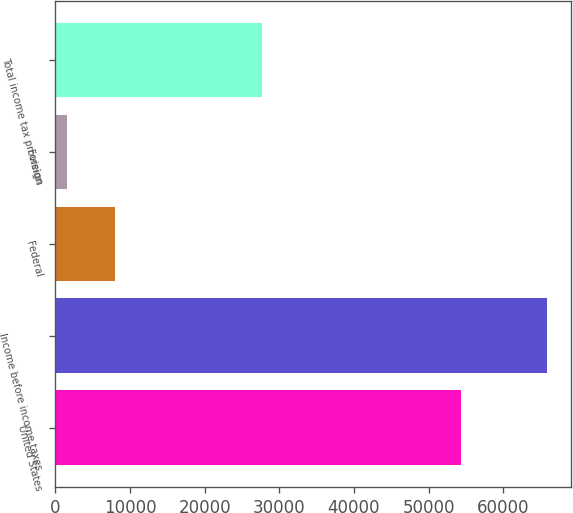Convert chart. <chart><loc_0><loc_0><loc_500><loc_500><bar_chart><fcel>United States<fcel>Income before income taxes<fcel>Federal<fcel>Foreign<fcel>Total income tax provision<nl><fcel>54406<fcel>65838<fcel>8016.6<fcel>1592<fcel>27691<nl></chart> 